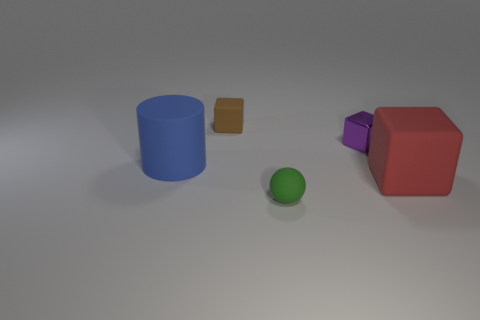There is a matte thing to the right of the purple metallic object; is it the same size as the object left of the brown rubber block?
Ensure brevity in your answer.  Yes. Is there a tiny green sphere made of the same material as the brown thing?
Your answer should be very brief. Yes. There is a rubber thing in front of the rubber cube in front of the brown object; is there a small ball that is to the left of it?
Your answer should be compact. No. There is a small shiny block; are there any purple metal things behind it?
Your answer should be very brief. No. What number of shiny objects are in front of the big rubber object that is on the right side of the cylinder?
Offer a very short reply. 0. There is a purple shiny block; is its size the same as the rubber thing in front of the big red matte object?
Your response must be concise. Yes. Are there any big cylinders that have the same color as the rubber ball?
Your answer should be compact. No. There is a cylinder that is the same material as the red cube; what is its size?
Provide a succinct answer. Large. Is the material of the small green sphere the same as the red cube?
Give a very brief answer. Yes. What color is the rubber cube that is in front of the rubber thing behind the thing that is to the left of the small brown object?
Give a very brief answer. Red. 